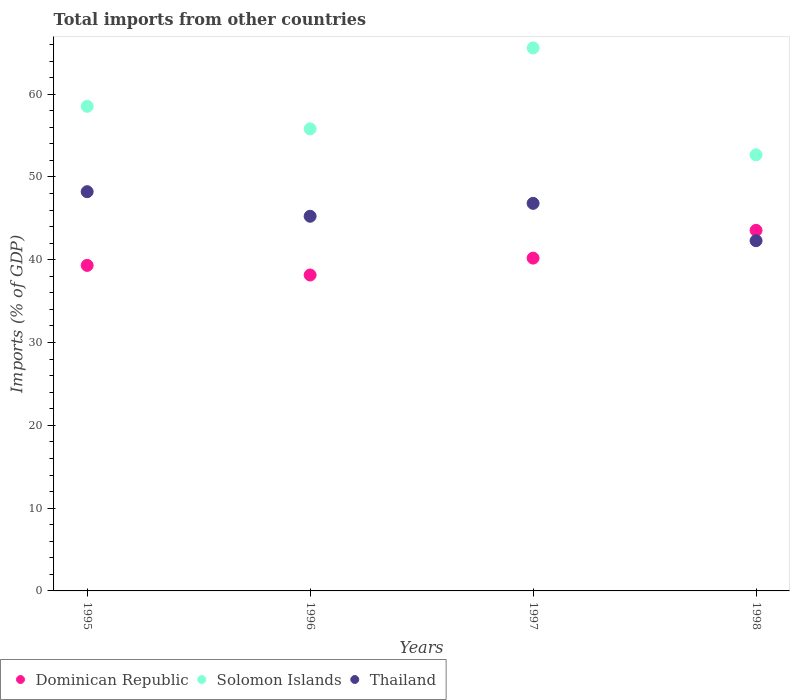Is the number of dotlines equal to the number of legend labels?
Provide a short and direct response. Yes. What is the total imports in Solomon Islands in 1998?
Your answer should be very brief. 52.67. Across all years, what is the maximum total imports in Dominican Republic?
Your response must be concise. 43.55. Across all years, what is the minimum total imports in Thailand?
Your answer should be very brief. 42.3. In which year was the total imports in Dominican Republic maximum?
Your response must be concise. 1998. What is the total total imports in Thailand in the graph?
Provide a short and direct response. 182.6. What is the difference between the total imports in Thailand in 1997 and that in 1998?
Offer a terse response. 4.51. What is the difference between the total imports in Dominican Republic in 1998 and the total imports in Solomon Islands in 1997?
Your answer should be compact. -22.04. What is the average total imports in Dominican Republic per year?
Make the answer very short. 40.31. In the year 1996, what is the difference between the total imports in Thailand and total imports in Dominican Republic?
Provide a succinct answer. 7.1. In how many years, is the total imports in Dominican Republic greater than 2 %?
Give a very brief answer. 4. What is the ratio of the total imports in Thailand in 1997 to that in 1998?
Ensure brevity in your answer.  1.11. Is the total imports in Solomon Islands in 1995 less than that in 1996?
Provide a short and direct response. No. Is the difference between the total imports in Thailand in 1996 and 1997 greater than the difference between the total imports in Dominican Republic in 1996 and 1997?
Make the answer very short. Yes. What is the difference between the highest and the second highest total imports in Thailand?
Your response must be concise. 1.41. What is the difference between the highest and the lowest total imports in Solomon Islands?
Offer a terse response. 12.92. In how many years, is the total imports in Dominican Republic greater than the average total imports in Dominican Republic taken over all years?
Make the answer very short. 1. Does the total imports in Thailand monotonically increase over the years?
Your response must be concise. No. How many dotlines are there?
Your answer should be compact. 3. What is the difference between two consecutive major ticks on the Y-axis?
Your response must be concise. 10. Does the graph contain any zero values?
Make the answer very short. No. What is the title of the graph?
Offer a very short reply. Total imports from other countries. What is the label or title of the X-axis?
Your answer should be very brief. Years. What is the label or title of the Y-axis?
Make the answer very short. Imports (% of GDP). What is the Imports (% of GDP) in Dominican Republic in 1995?
Ensure brevity in your answer.  39.32. What is the Imports (% of GDP) in Solomon Islands in 1995?
Offer a terse response. 58.53. What is the Imports (% of GDP) in Thailand in 1995?
Provide a succinct answer. 48.22. What is the Imports (% of GDP) of Dominican Republic in 1996?
Offer a very short reply. 38.16. What is the Imports (% of GDP) of Solomon Islands in 1996?
Offer a very short reply. 55.81. What is the Imports (% of GDP) in Thailand in 1996?
Ensure brevity in your answer.  45.26. What is the Imports (% of GDP) in Dominican Republic in 1997?
Keep it short and to the point. 40.2. What is the Imports (% of GDP) in Solomon Islands in 1997?
Keep it short and to the point. 65.59. What is the Imports (% of GDP) of Thailand in 1997?
Give a very brief answer. 46.81. What is the Imports (% of GDP) of Dominican Republic in 1998?
Give a very brief answer. 43.55. What is the Imports (% of GDP) of Solomon Islands in 1998?
Offer a very short reply. 52.67. What is the Imports (% of GDP) of Thailand in 1998?
Offer a terse response. 42.3. Across all years, what is the maximum Imports (% of GDP) in Dominican Republic?
Give a very brief answer. 43.55. Across all years, what is the maximum Imports (% of GDP) in Solomon Islands?
Your answer should be very brief. 65.59. Across all years, what is the maximum Imports (% of GDP) in Thailand?
Your answer should be very brief. 48.22. Across all years, what is the minimum Imports (% of GDP) in Dominican Republic?
Ensure brevity in your answer.  38.16. Across all years, what is the minimum Imports (% of GDP) in Solomon Islands?
Give a very brief answer. 52.67. Across all years, what is the minimum Imports (% of GDP) in Thailand?
Your response must be concise. 42.3. What is the total Imports (% of GDP) of Dominican Republic in the graph?
Offer a terse response. 161.23. What is the total Imports (% of GDP) in Solomon Islands in the graph?
Your answer should be compact. 232.6. What is the total Imports (% of GDP) of Thailand in the graph?
Your answer should be compact. 182.6. What is the difference between the Imports (% of GDP) in Dominican Republic in 1995 and that in 1996?
Offer a terse response. 1.16. What is the difference between the Imports (% of GDP) in Solomon Islands in 1995 and that in 1996?
Make the answer very short. 2.72. What is the difference between the Imports (% of GDP) of Thailand in 1995 and that in 1996?
Provide a succinct answer. 2.97. What is the difference between the Imports (% of GDP) in Dominican Republic in 1995 and that in 1997?
Keep it short and to the point. -0.88. What is the difference between the Imports (% of GDP) in Solomon Islands in 1995 and that in 1997?
Your answer should be compact. -7.06. What is the difference between the Imports (% of GDP) of Thailand in 1995 and that in 1997?
Your answer should be very brief. 1.41. What is the difference between the Imports (% of GDP) in Dominican Republic in 1995 and that in 1998?
Your answer should be very brief. -4.23. What is the difference between the Imports (% of GDP) in Solomon Islands in 1995 and that in 1998?
Offer a very short reply. 5.86. What is the difference between the Imports (% of GDP) in Thailand in 1995 and that in 1998?
Keep it short and to the point. 5.92. What is the difference between the Imports (% of GDP) of Dominican Republic in 1996 and that in 1997?
Ensure brevity in your answer.  -2.04. What is the difference between the Imports (% of GDP) in Solomon Islands in 1996 and that in 1997?
Give a very brief answer. -9.78. What is the difference between the Imports (% of GDP) in Thailand in 1996 and that in 1997?
Provide a short and direct response. -1.56. What is the difference between the Imports (% of GDP) in Dominican Republic in 1996 and that in 1998?
Your answer should be compact. -5.39. What is the difference between the Imports (% of GDP) of Solomon Islands in 1996 and that in 1998?
Offer a very short reply. 3.14. What is the difference between the Imports (% of GDP) of Thailand in 1996 and that in 1998?
Offer a very short reply. 2.95. What is the difference between the Imports (% of GDP) of Dominican Republic in 1997 and that in 1998?
Ensure brevity in your answer.  -3.35. What is the difference between the Imports (% of GDP) of Solomon Islands in 1997 and that in 1998?
Provide a succinct answer. 12.92. What is the difference between the Imports (% of GDP) of Thailand in 1997 and that in 1998?
Provide a succinct answer. 4.51. What is the difference between the Imports (% of GDP) of Dominican Republic in 1995 and the Imports (% of GDP) of Solomon Islands in 1996?
Give a very brief answer. -16.49. What is the difference between the Imports (% of GDP) in Dominican Republic in 1995 and the Imports (% of GDP) in Thailand in 1996?
Offer a terse response. -5.93. What is the difference between the Imports (% of GDP) in Solomon Islands in 1995 and the Imports (% of GDP) in Thailand in 1996?
Offer a terse response. 13.28. What is the difference between the Imports (% of GDP) of Dominican Republic in 1995 and the Imports (% of GDP) of Solomon Islands in 1997?
Offer a terse response. -26.27. What is the difference between the Imports (% of GDP) in Dominican Republic in 1995 and the Imports (% of GDP) in Thailand in 1997?
Provide a short and direct response. -7.49. What is the difference between the Imports (% of GDP) of Solomon Islands in 1995 and the Imports (% of GDP) of Thailand in 1997?
Offer a very short reply. 11.72. What is the difference between the Imports (% of GDP) of Dominican Republic in 1995 and the Imports (% of GDP) of Solomon Islands in 1998?
Your answer should be compact. -13.35. What is the difference between the Imports (% of GDP) in Dominican Republic in 1995 and the Imports (% of GDP) in Thailand in 1998?
Make the answer very short. -2.98. What is the difference between the Imports (% of GDP) in Solomon Islands in 1995 and the Imports (% of GDP) in Thailand in 1998?
Make the answer very short. 16.23. What is the difference between the Imports (% of GDP) in Dominican Republic in 1996 and the Imports (% of GDP) in Solomon Islands in 1997?
Keep it short and to the point. -27.43. What is the difference between the Imports (% of GDP) in Dominican Republic in 1996 and the Imports (% of GDP) in Thailand in 1997?
Make the answer very short. -8.65. What is the difference between the Imports (% of GDP) in Solomon Islands in 1996 and the Imports (% of GDP) in Thailand in 1997?
Give a very brief answer. 8.99. What is the difference between the Imports (% of GDP) in Dominican Republic in 1996 and the Imports (% of GDP) in Solomon Islands in 1998?
Make the answer very short. -14.51. What is the difference between the Imports (% of GDP) in Dominican Republic in 1996 and the Imports (% of GDP) in Thailand in 1998?
Provide a short and direct response. -4.14. What is the difference between the Imports (% of GDP) of Solomon Islands in 1996 and the Imports (% of GDP) of Thailand in 1998?
Ensure brevity in your answer.  13.51. What is the difference between the Imports (% of GDP) in Dominican Republic in 1997 and the Imports (% of GDP) in Solomon Islands in 1998?
Your answer should be compact. -12.47. What is the difference between the Imports (% of GDP) of Dominican Republic in 1997 and the Imports (% of GDP) of Thailand in 1998?
Your answer should be compact. -2.1. What is the difference between the Imports (% of GDP) in Solomon Islands in 1997 and the Imports (% of GDP) in Thailand in 1998?
Ensure brevity in your answer.  23.29. What is the average Imports (% of GDP) in Dominican Republic per year?
Give a very brief answer. 40.31. What is the average Imports (% of GDP) in Solomon Islands per year?
Make the answer very short. 58.15. What is the average Imports (% of GDP) in Thailand per year?
Your answer should be compact. 45.65. In the year 1995, what is the difference between the Imports (% of GDP) of Dominican Republic and Imports (% of GDP) of Solomon Islands?
Ensure brevity in your answer.  -19.21. In the year 1995, what is the difference between the Imports (% of GDP) in Dominican Republic and Imports (% of GDP) in Thailand?
Ensure brevity in your answer.  -8.9. In the year 1995, what is the difference between the Imports (% of GDP) of Solomon Islands and Imports (% of GDP) of Thailand?
Give a very brief answer. 10.31. In the year 1996, what is the difference between the Imports (% of GDP) in Dominican Republic and Imports (% of GDP) in Solomon Islands?
Offer a terse response. -17.65. In the year 1996, what is the difference between the Imports (% of GDP) in Dominican Republic and Imports (% of GDP) in Thailand?
Offer a terse response. -7.1. In the year 1996, what is the difference between the Imports (% of GDP) of Solomon Islands and Imports (% of GDP) of Thailand?
Give a very brief answer. 10.55. In the year 1997, what is the difference between the Imports (% of GDP) of Dominican Republic and Imports (% of GDP) of Solomon Islands?
Provide a short and direct response. -25.39. In the year 1997, what is the difference between the Imports (% of GDP) of Dominican Republic and Imports (% of GDP) of Thailand?
Offer a terse response. -6.61. In the year 1997, what is the difference between the Imports (% of GDP) in Solomon Islands and Imports (% of GDP) in Thailand?
Offer a very short reply. 18.77. In the year 1998, what is the difference between the Imports (% of GDP) in Dominican Republic and Imports (% of GDP) in Solomon Islands?
Your answer should be compact. -9.12. In the year 1998, what is the difference between the Imports (% of GDP) in Dominican Republic and Imports (% of GDP) in Thailand?
Provide a short and direct response. 1.25. In the year 1998, what is the difference between the Imports (% of GDP) of Solomon Islands and Imports (% of GDP) of Thailand?
Your answer should be very brief. 10.37. What is the ratio of the Imports (% of GDP) in Dominican Republic in 1995 to that in 1996?
Your response must be concise. 1.03. What is the ratio of the Imports (% of GDP) of Solomon Islands in 1995 to that in 1996?
Offer a very short reply. 1.05. What is the ratio of the Imports (% of GDP) in Thailand in 1995 to that in 1996?
Your answer should be compact. 1.07. What is the ratio of the Imports (% of GDP) in Dominican Republic in 1995 to that in 1997?
Ensure brevity in your answer.  0.98. What is the ratio of the Imports (% of GDP) in Solomon Islands in 1995 to that in 1997?
Provide a succinct answer. 0.89. What is the ratio of the Imports (% of GDP) of Thailand in 1995 to that in 1997?
Keep it short and to the point. 1.03. What is the ratio of the Imports (% of GDP) of Dominican Republic in 1995 to that in 1998?
Provide a succinct answer. 0.9. What is the ratio of the Imports (% of GDP) in Solomon Islands in 1995 to that in 1998?
Offer a very short reply. 1.11. What is the ratio of the Imports (% of GDP) of Thailand in 1995 to that in 1998?
Keep it short and to the point. 1.14. What is the ratio of the Imports (% of GDP) in Dominican Republic in 1996 to that in 1997?
Your response must be concise. 0.95. What is the ratio of the Imports (% of GDP) in Solomon Islands in 1996 to that in 1997?
Keep it short and to the point. 0.85. What is the ratio of the Imports (% of GDP) of Thailand in 1996 to that in 1997?
Make the answer very short. 0.97. What is the ratio of the Imports (% of GDP) in Dominican Republic in 1996 to that in 1998?
Your answer should be compact. 0.88. What is the ratio of the Imports (% of GDP) of Solomon Islands in 1996 to that in 1998?
Ensure brevity in your answer.  1.06. What is the ratio of the Imports (% of GDP) in Thailand in 1996 to that in 1998?
Ensure brevity in your answer.  1.07. What is the ratio of the Imports (% of GDP) in Dominican Republic in 1997 to that in 1998?
Your response must be concise. 0.92. What is the ratio of the Imports (% of GDP) in Solomon Islands in 1997 to that in 1998?
Make the answer very short. 1.25. What is the ratio of the Imports (% of GDP) of Thailand in 1997 to that in 1998?
Provide a succinct answer. 1.11. What is the difference between the highest and the second highest Imports (% of GDP) of Dominican Republic?
Your answer should be very brief. 3.35. What is the difference between the highest and the second highest Imports (% of GDP) of Solomon Islands?
Make the answer very short. 7.06. What is the difference between the highest and the second highest Imports (% of GDP) of Thailand?
Keep it short and to the point. 1.41. What is the difference between the highest and the lowest Imports (% of GDP) of Dominican Republic?
Make the answer very short. 5.39. What is the difference between the highest and the lowest Imports (% of GDP) of Solomon Islands?
Provide a succinct answer. 12.92. What is the difference between the highest and the lowest Imports (% of GDP) in Thailand?
Make the answer very short. 5.92. 